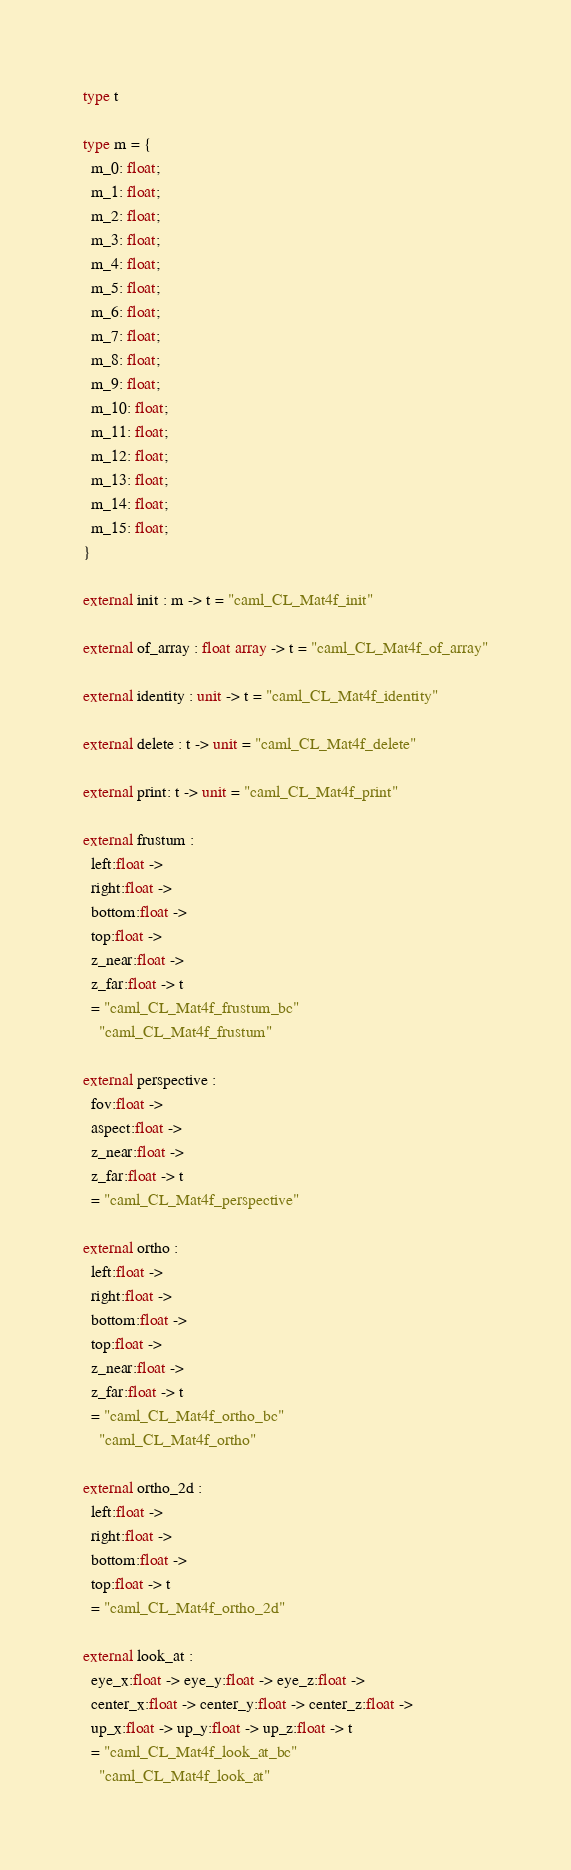Convert code to text. <code><loc_0><loc_0><loc_500><loc_500><_OCaml_>type t

type m = {
  m_0: float;
  m_1: float;
  m_2: float;
  m_3: float;
  m_4: float;
  m_5: float;
  m_6: float;
  m_7: float;
  m_8: float;
  m_9: float;
  m_10: float;
  m_11: float;
  m_12: float;
  m_13: float;
  m_14: float;
  m_15: float;
}

external init : m -> t = "caml_CL_Mat4f_init"

external of_array : float array -> t = "caml_CL_Mat4f_of_array"

external identity : unit -> t = "caml_CL_Mat4f_identity"

external delete : t -> unit = "caml_CL_Mat4f_delete"

external print: t -> unit = "caml_CL_Mat4f_print"

external frustum :
  left:float ->
  right:float ->
  bottom:float ->
  top:float ->
  z_near:float ->
  z_far:float -> t
  = "caml_CL_Mat4f_frustum_bc"
    "caml_CL_Mat4f_frustum"

external perspective : 
  fov:float ->
  aspect:float ->
  z_near:float ->
  z_far:float -> t
  = "caml_CL_Mat4f_perspective"

external ortho :
  left:float ->
  right:float ->
  bottom:float ->
  top:float ->
  z_near:float ->
  z_far:float -> t
  = "caml_CL_Mat4f_ortho_bc"
    "caml_CL_Mat4f_ortho"

external ortho_2d :
  left:float ->
  right:float ->
  bottom:float ->
  top:float -> t
  = "caml_CL_Mat4f_ortho_2d"

external look_at :
  eye_x:float -> eye_y:float -> eye_z:float ->
  center_x:float -> center_y:float -> center_z:float ->
  up_x:float -> up_y:float -> up_z:float -> t
  = "caml_CL_Mat4f_look_at_bc"
    "caml_CL_Mat4f_look_at"
</code> 